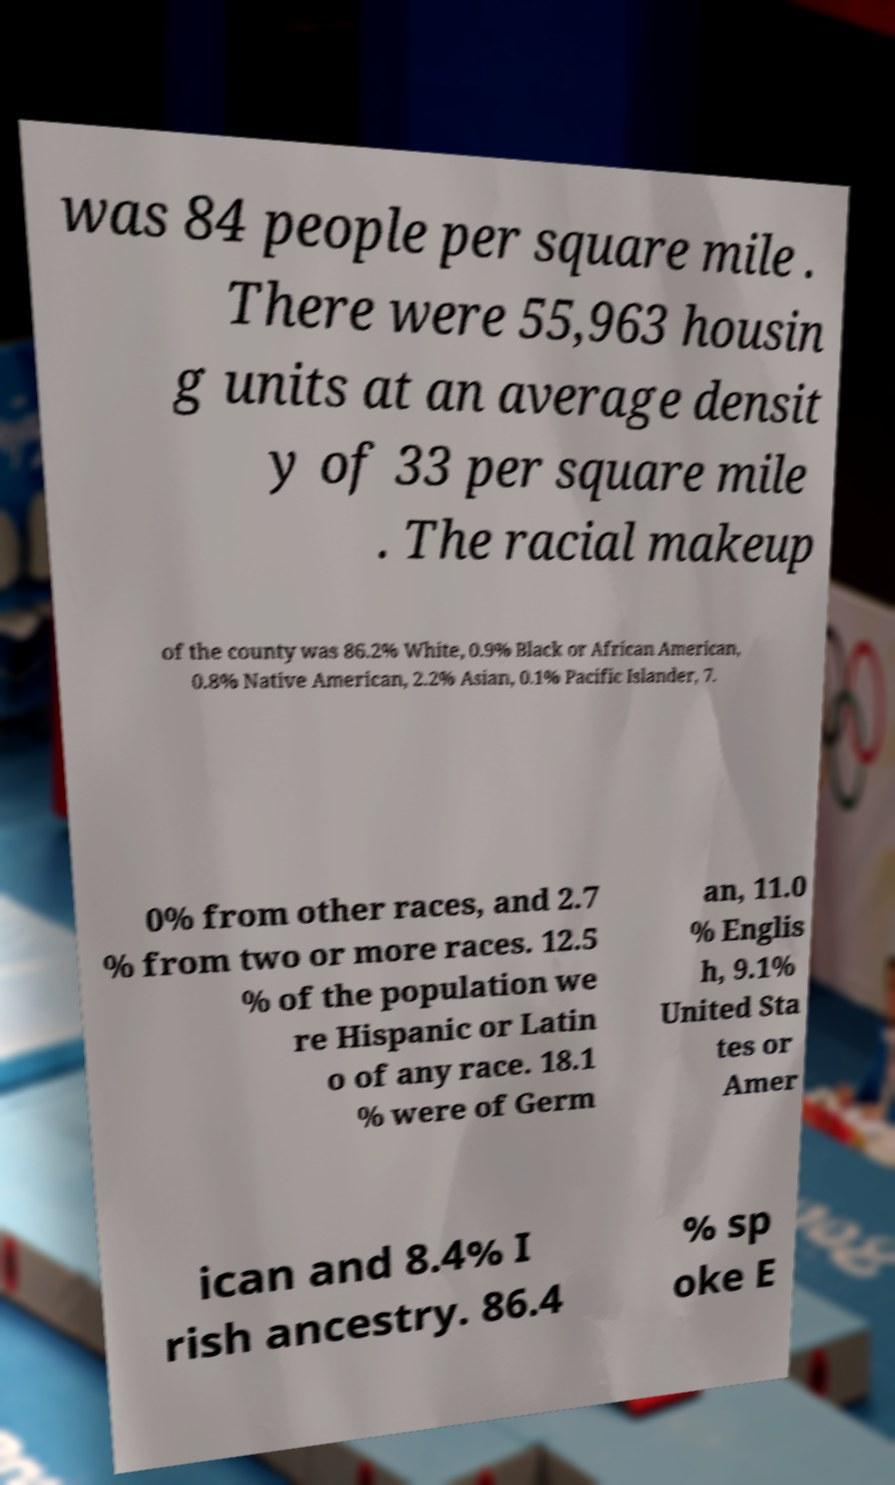Please read and relay the text visible in this image. What does it say? was 84 people per square mile . There were 55,963 housin g units at an average densit y of 33 per square mile . The racial makeup of the county was 86.2% White, 0.9% Black or African American, 0.8% Native American, 2.2% Asian, 0.1% Pacific Islander, 7. 0% from other races, and 2.7 % from two or more races. 12.5 % of the population we re Hispanic or Latin o of any race. 18.1 % were of Germ an, 11.0 % Englis h, 9.1% United Sta tes or Amer ican and 8.4% I rish ancestry. 86.4 % sp oke E 